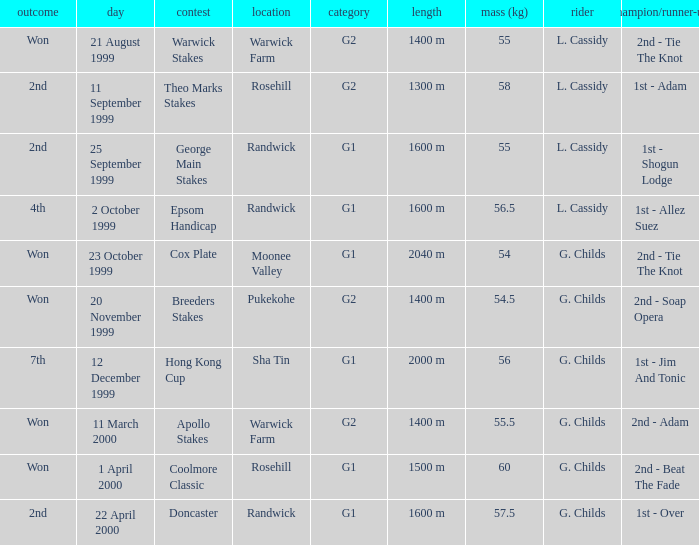How man teams had a total weight of 57.5? 1.0. 